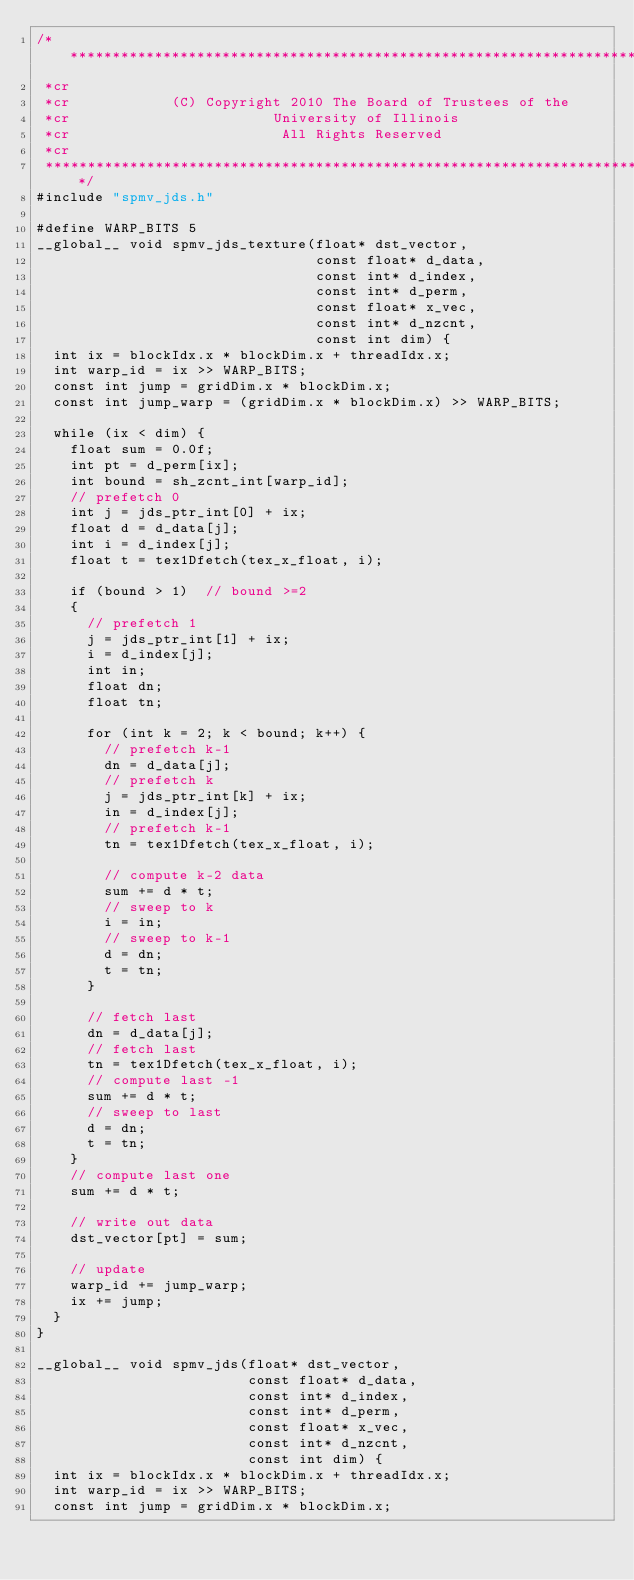Convert code to text. <code><loc_0><loc_0><loc_500><loc_500><_Cuda_>/***************************************************************************
 *cr
 *cr            (C) Copyright 2010 The Board of Trustees of the
 *cr                        University of Illinois
 *cr                         All Rights Reserved
 *cr
 ***************************************************************************/
#include "spmv_jds.h"

#define WARP_BITS 5
__global__ void spmv_jds_texture(float* dst_vector,
                                 const float* d_data,
                                 const int* d_index,
                                 const int* d_perm,
                                 const float* x_vec,
                                 const int* d_nzcnt,
                                 const int dim) {
  int ix = blockIdx.x * blockDim.x + threadIdx.x;
  int warp_id = ix >> WARP_BITS;
  const int jump = gridDim.x * blockDim.x;
  const int jump_warp = (gridDim.x * blockDim.x) >> WARP_BITS;

  while (ix < dim) {
    float sum = 0.0f;
    int pt = d_perm[ix];
    int bound = sh_zcnt_int[warp_id];
    // prefetch 0
    int j = jds_ptr_int[0] + ix;
    float d = d_data[j];
    int i = d_index[j];
    float t = tex1Dfetch(tex_x_float, i);

    if (bound > 1)  // bound >=2
    {
      // prefetch 1
      j = jds_ptr_int[1] + ix;
      i = d_index[j];
      int in;
      float dn;
      float tn;

      for (int k = 2; k < bound; k++) {
        // prefetch k-1
        dn = d_data[j];
        // prefetch k
        j = jds_ptr_int[k] + ix;
        in = d_index[j];
        // prefetch k-1
        tn = tex1Dfetch(tex_x_float, i);

        // compute k-2 data
        sum += d * t;
        // sweep to k
        i = in;
        // sweep to k-1
        d = dn;
        t = tn;
      }

      // fetch last
      dn = d_data[j];
      // fetch last
      tn = tex1Dfetch(tex_x_float, i);
      // compute last -1
      sum += d * t;
      // sweep to last
      d = dn;
      t = tn;
    }
    // compute last one
    sum += d * t;

    // write out data
    dst_vector[pt] = sum;

    // update
    warp_id += jump_warp;
    ix += jump;
  }
}

__global__ void spmv_jds(float* dst_vector,
                         const float* d_data,
                         const int* d_index,
                         const int* d_perm,
                         const float* x_vec,
                         const int* d_nzcnt,
                         const int dim) {
  int ix = blockIdx.x * blockDim.x + threadIdx.x;
  int warp_id = ix >> WARP_BITS;
  const int jump = gridDim.x * blockDim.x;</code> 